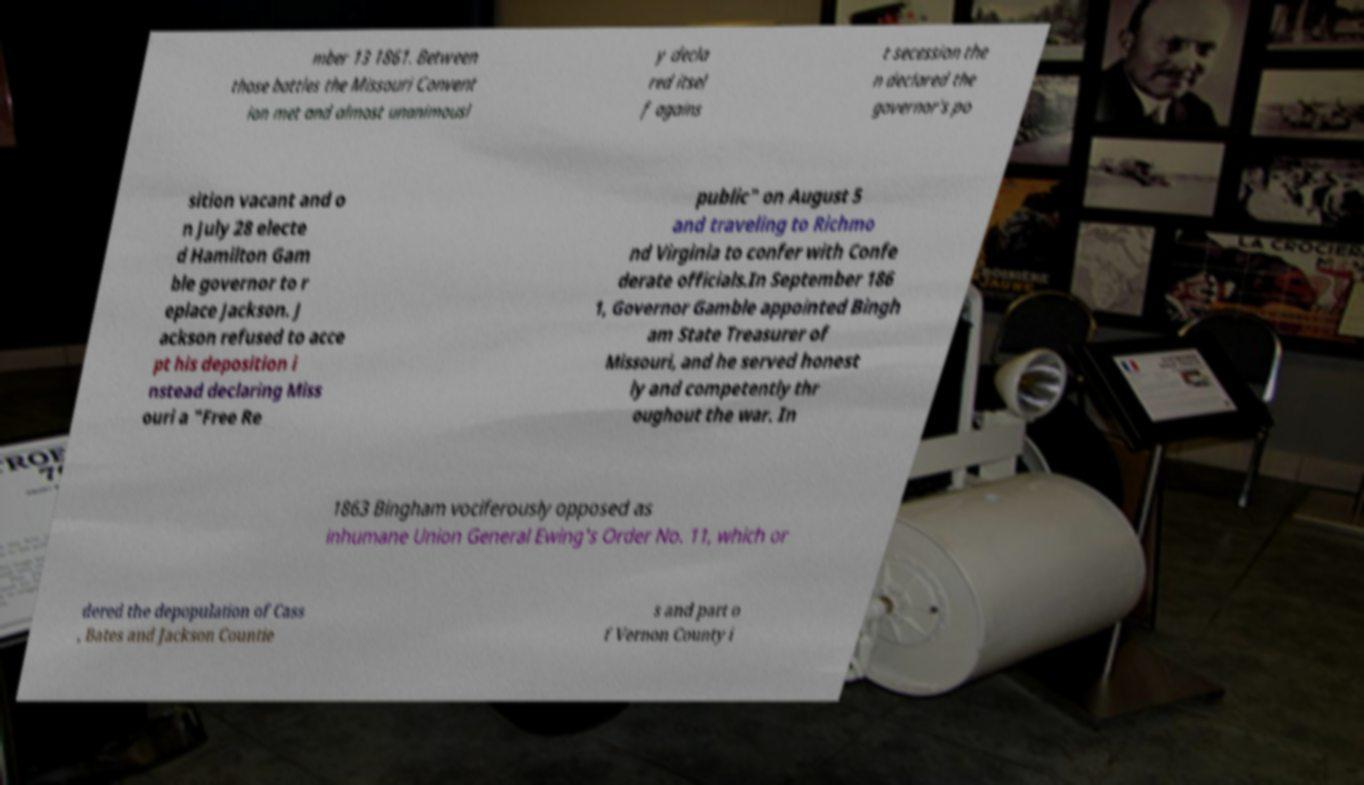Can you read and provide the text displayed in the image?This photo seems to have some interesting text. Can you extract and type it out for me? mber 13 1861. Between those battles the Missouri Convent ion met and almost unanimousl y decla red itsel f agains t secession the n declared the governor's po sition vacant and o n July 28 electe d Hamilton Gam ble governor to r eplace Jackson. J ackson refused to acce pt his deposition i nstead declaring Miss ouri a "Free Re public" on August 5 and traveling to Richmo nd Virginia to confer with Confe derate officials.In September 186 1, Governor Gamble appointed Bingh am State Treasurer of Missouri, and he served honest ly and competently thr oughout the war. In 1863 Bingham vociferously opposed as inhumane Union General Ewing's Order No. 11, which or dered the depopulation of Cass , Bates and Jackson Countie s and part o f Vernon County i 